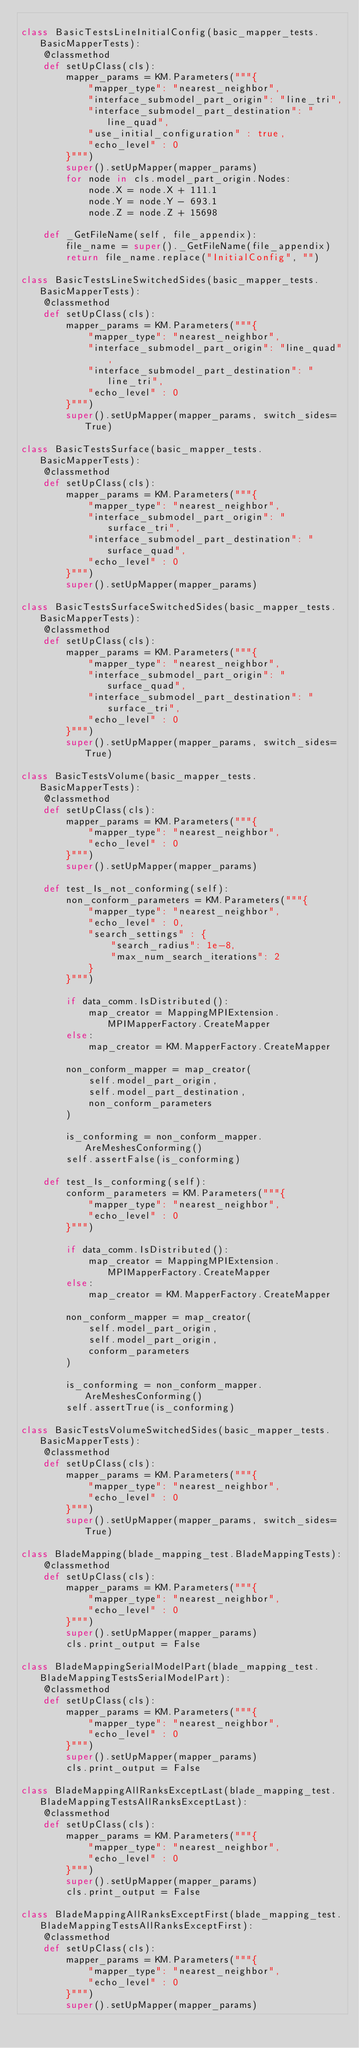<code> <loc_0><loc_0><loc_500><loc_500><_Python_>
class BasicTestsLineInitialConfig(basic_mapper_tests.BasicMapperTests):
    @classmethod
    def setUpClass(cls):
        mapper_params = KM.Parameters("""{
            "mapper_type": "nearest_neighbor",
            "interface_submodel_part_origin": "line_tri",
            "interface_submodel_part_destination": "line_quad",
            "use_initial_configuration" : true,
            "echo_level" : 0
        }""")
        super().setUpMapper(mapper_params)
        for node in cls.model_part_origin.Nodes:
            node.X = node.X + 111.1
            node.Y = node.Y - 693.1
            node.Z = node.Z + 15698

    def _GetFileName(self, file_appendix):
        file_name = super()._GetFileName(file_appendix)
        return file_name.replace("InitialConfig", "")

class BasicTestsLineSwitchedSides(basic_mapper_tests.BasicMapperTests):
    @classmethod
    def setUpClass(cls):
        mapper_params = KM.Parameters("""{
            "mapper_type": "nearest_neighbor",
            "interface_submodel_part_origin": "line_quad",
            "interface_submodel_part_destination": "line_tri",
            "echo_level" : 0
        }""")
        super().setUpMapper(mapper_params, switch_sides=True)

class BasicTestsSurface(basic_mapper_tests.BasicMapperTests):
    @classmethod
    def setUpClass(cls):
        mapper_params = KM.Parameters("""{
            "mapper_type": "nearest_neighbor",
            "interface_submodel_part_origin": "surface_tri",
            "interface_submodel_part_destination": "surface_quad",
            "echo_level" : 0
        }""")
        super().setUpMapper(mapper_params)

class BasicTestsSurfaceSwitchedSides(basic_mapper_tests.BasicMapperTests):
    @classmethod
    def setUpClass(cls):
        mapper_params = KM.Parameters("""{
            "mapper_type": "nearest_neighbor",
            "interface_submodel_part_origin": "surface_quad",
            "interface_submodel_part_destination": "surface_tri",
            "echo_level" : 0
        }""")
        super().setUpMapper(mapper_params, switch_sides=True)

class BasicTestsVolume(basic_mapper_tests.BasicMapperTests):
    @classmethod
    def setUpClass(cls):
        mapper_params = KM.Parameters("""{
            "mapper_type": "nearest_neighbor",
            "echo_level" : 0
        }""")
        super().setUpMapper(mapper_params)

    def test_Is_not_conforming(self):
        non_conform_parameters = KM.Parameters("""{
            "mapper_type": "nearest_neighbor",
            "echo_level" : 0,
            "search_settings" : {
                "search_radius": 1e-8,
                "max_num_search_iterations": 2
            }
        }""")

        if data_comm.IsDistributed():
            map_creator = MappingMPIExtension.MPIMapperFactory.CreateMapper
        else:
            map_creator = KM.MapperFactory.CreateMapper

        non_conform_mapper = map_creator(
            self.model_part_origin,
            self.model_part_destination,
            non_conform_parameters
        )

        is_conforming = non_conform_mapper.AreMeshesConforming()
        self.assertFalse(is_conforming)

    def test_Is_conforming(self):
        conform_parameters = KM.Parameters("""{
            "mapper_type": "nearest_neighbor",
            "echo_level" : 0
        }""")

        if data_comm.IsDistributed():
            map_creator = MappingMPIExtension.MPIMapperFactory.CreateMapper
        else:
            map_creator = KM.MapperFactory.CreateMapper

        non_conform_mapper = map_creator(
            self.model_part_origin,
            self.model_part_origin,
            conform_parameters
        )

        is_conforming = non_conform_mapper.AreMeshesConforming()
        self.assertTrue(is_conforming)

class BasicTestsVolumeSwitchedSides(basic_mapper_tests.BasicMapperTests):
    @classmethod
    def setUpClass(cls):
        mapper_params = KM.Parameters("""{
            "mapper_type": "nearest_neighbor",
            "echo_level" : 0
        }""")
        super().setUpMapper(mapper_params, switch_sides=True)

class BladeMapping(blade_mapping_test.BladeMappingTests):
    @classmethod
    def setUpClass(cls):
        mapper_params = KM.Parameters("""{
            "mapper_type": "nearest_neighbor",
            "echo_level" : 0
        }""")
        super().setUpMapper(mapper_params)
        cls.print_output = False

class BladeMappingSerialModelPart(blade_mapping_test.BladeMappingTestsSerialModelPart):
    @classmethod
    def setUpClass(cls):
        mapper_params = KM.Parameters("""{
            "mapper_type": "nearest_neighbor",
            "echo_level" : 0
        }""")
        super().setUpMapper(mapper_params)
        cls.print_output = False

class BladeMappingAllRanksExceptLast(blade_mapping_test.BladeMappingTestsAllRanksExceptLast):
    @classmethod
    def setUpClass(cls):
        mapper_params = KM.Parameters("""{
            "mapper_type": "nearest_neighbor",
            "echo_level" : 0
        }""")
        super().setUpMapper(mapper_params)
        cls.print_output = False

class BladeMappingAllRanksExceptFirst(blade_mapping_test.BladeMappingTestsAllRanksExceptFirst):
    @classmethod
    def setUpClass(cls):
        mapper_params = KM.Parameters("""{
            "mapper_type": "nearest_neighbor",
            "echo_level" : 0
        }""")
        super().setUpMapper(mapper_params)</code> 